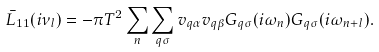Convert formula to latex. <formula><loc_0><loc_0><loc_500><loc_500>\bar { L } _ { 1 1 } ( i \nu _ { l } ) = - \pi T ^ { 2 } \sum _ { n } \sum _ { q \sigma } { v } _ { q \alpha } { v } _ { q \beta } G _ { q \sigma } ( i \omega _ { n } ) G _ { q \sigma } ( i \omega _ { n + l } ) .</formula> 